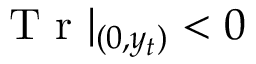Convert formula to latex. <formula><loc_0><loc_0><loc_500><loc_500>T r | _ { ( 0 , y _ { t } ) } < 0</formula> 